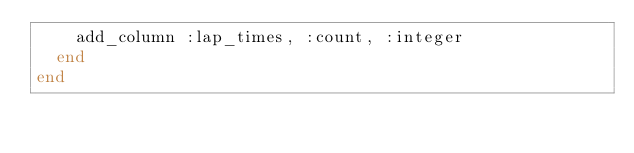<code> <loc_0><loc_0><loc_500><loc_500><_Ruby_>    add_column :lap_times, :count, :integer
  end
end
</code> 